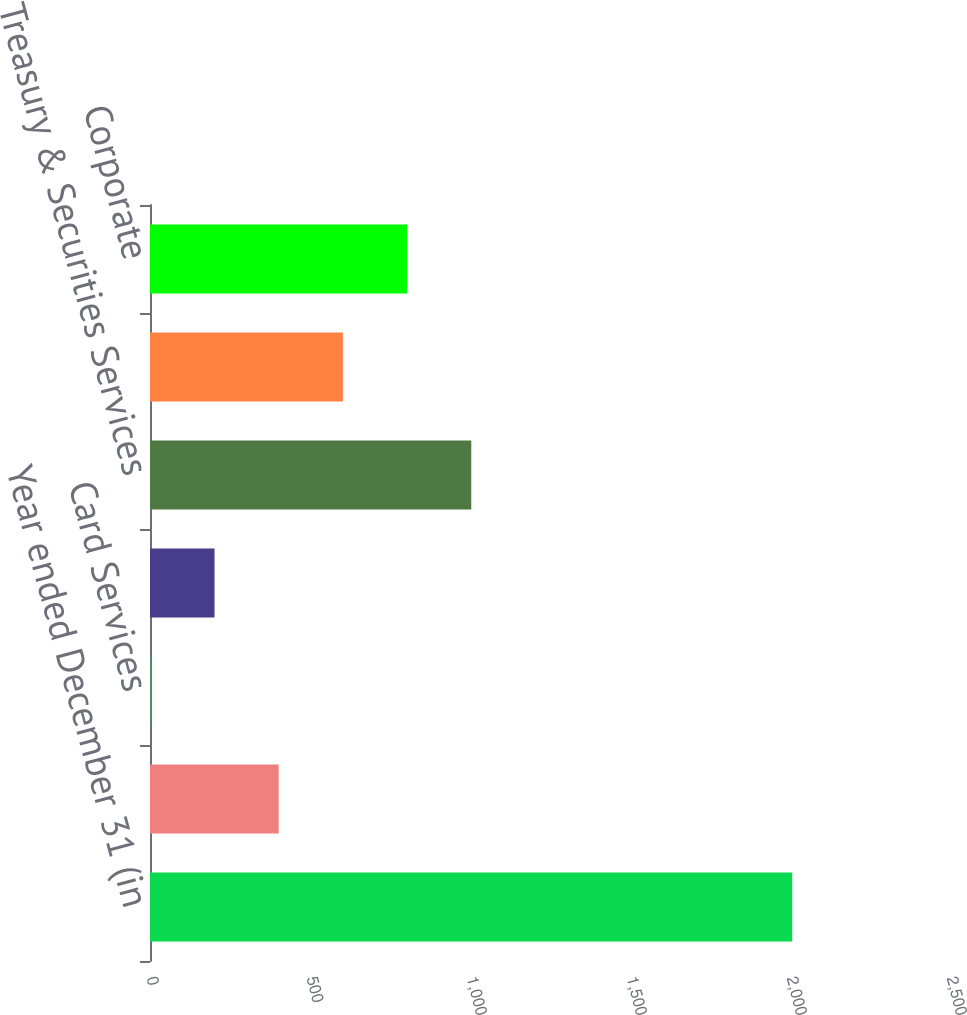Convert chart to OTSL. <chart><loc_0><loc_0><loc_500><loc_500><bar_chart><fcel>Year ended December 31 (in<fcel>Retail Financial Services<fcel>Card Services<fcel>Commercial Banking<fcel>Treasury & Securities Services<fcel>Asset Management<fcel>Corporate<nl><fcel>2007<fcel>402.2<fcel>1<fcel>201.6<fcel>1004<fcel>602.8<fcel>803.4<nl></chart> 